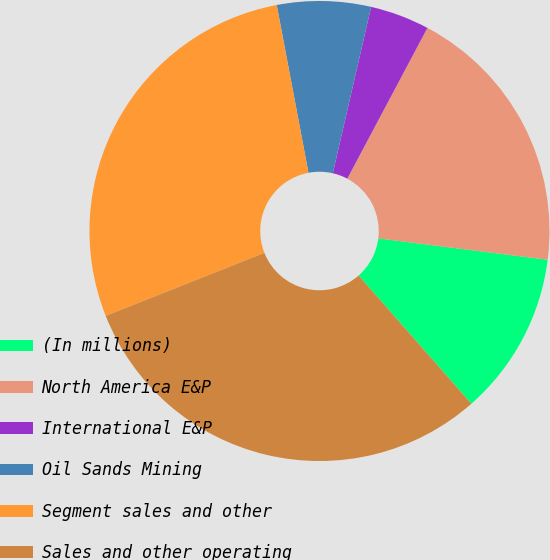Convert chart. <chart><loc_0><loc_0><loc_500><loc_500><pie_chart><fcel>(In millions)<fcel>North America E&P<fcel>International E&P<fcel>Oil Sands Mining<fcel>Segment sales and other<fcel>Sales and other operating<nl><fcel>11.53%<fcel>19.22%<fcel>4.17%<fcel>6.58%<fcel>28.04%<fcel>30.46%<nl></chart> 